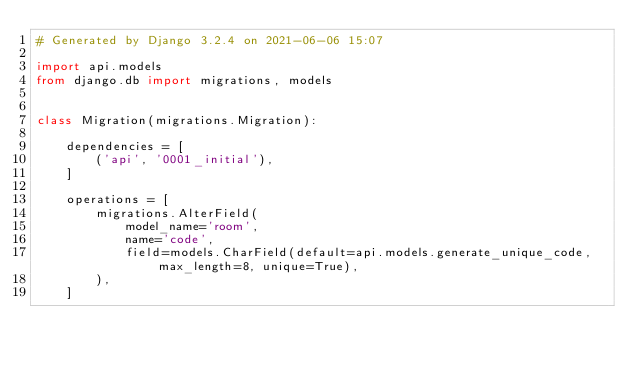<code> <loc_0><loc_0><loc_500><loc_500><_Python_># Generated by Django 3.2.4 on 2021-06-06 15:07

import api.models
from django.db import migrations, models


class Migration(migrations.Migration):

    dependencies = [
        ('api', '0001_initial'),
    ]

    operations = [
        migrations.AlterField(
            model_name='room',
            name='code',
            field=models.CharField(default=api.models.generate_unique_code, max_length=8, unique=True),
        ),
    ]
</code> 